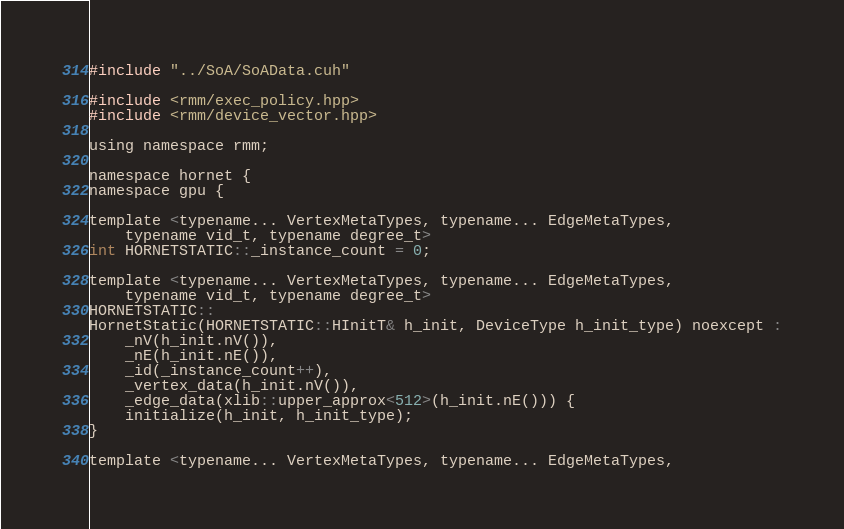<code> <loc_0><loc_0><loc_500><loc_500><_Cuda_>#include "../SoA/SoAData.cuh"

#include <rmm/exec_policy.hpp>
#include <rmm/device_vector.hpp>

using namespace rmm;

namespace hornet {
namespace gpu {

template <typename... VertexMetaTypes, typename... EdgeMetaTypes,
    typename vid_t, typename degree_t>
int HORNETSTATIC::_instance_count = 0;

template <typename... VertexMetaTypes, typename... EdgeMetaTypes,
    typename vid_t, typename degree_t>
HORNETSTATIC::
HornetStatic(HORNETSTATIC::HInitT& h_init, DeviceType h_init_type) noexcept :
    _nV(h_init.nV()),
    _nE(h_init.nE()),
    _id(_instance_count++),
    _vertex_data(h_init.nV()),
    _edge_data(xlib::upper_approx<512>(h_init.nE())) {
    initialize(h_init, h_init_type);
}

template <typename... VertexMetaTypes, typename... EdgeMetaTypes,</code> 